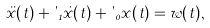Convert formula to latex. <formula><loc_0><loc_0><loc_500><loc_500>\ddot { x } ( t ) + \theta _ { 1 } \dot { x } ( t ) + \theta _ { 0 } x ( t ) = w ( t ) ,</formula> 